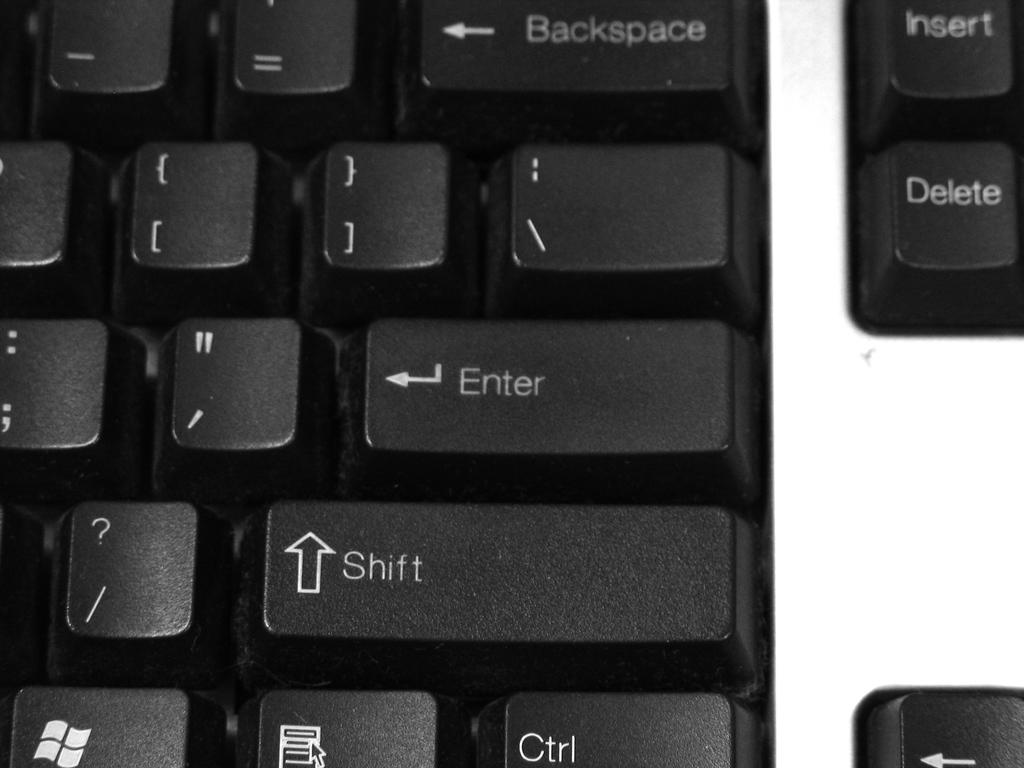<image>
Render a clear and concise summary of the photo. A black keyboard has a Backspace key, an Enter key, and a Shift key. 